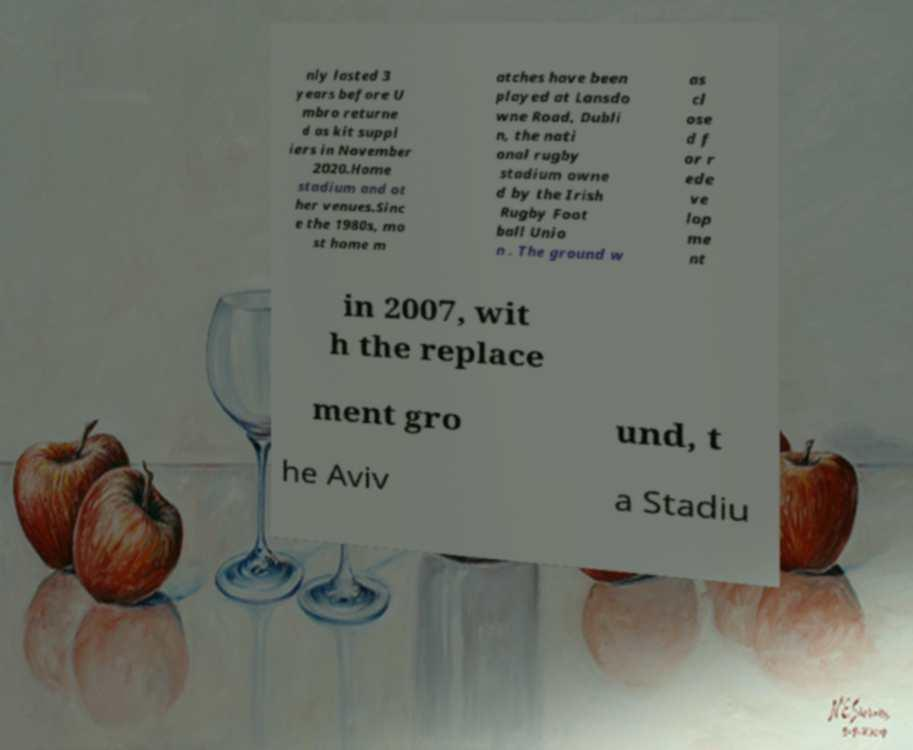For documentation purposes, I need the text within this image transcribed. Could you provide that? nly lasted 3 years before U mbro returne d as kit suppl iers in November 2020.Home stadium and ot her venues.Sinc e the 1980s, mo st home m atches have been played at Lansdo wne Road, Dubli n, the nati onal rugby stadium owne d by the Irish Rugby Foot ball Unio n . The ground w as cl ose d f or r ede ve lop me nt in 2007, wit h the replace ment gro und, t he Aviv a Stadiu 